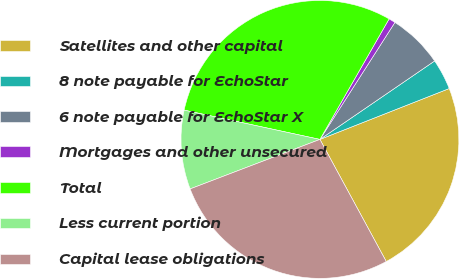Convert chart. <chart><loc_0><loc_0><loc_500><loc_500><pie_chart><fcel>Satellites and other capital<fcel>8 note payable for EchoStar<fcel>6 note payable for EchoStar X<fcel>Mortgages and other unsecured<fcel>Total<fcel>Less current portion<fcel>Capital lease obligations<nl><fcel>23.05%<fcel>3.58%<fcel>6.38%<fcel>0.78%<fcel>29.91%<fcel>9.18%<fcel>27.12%<nl></chart> 